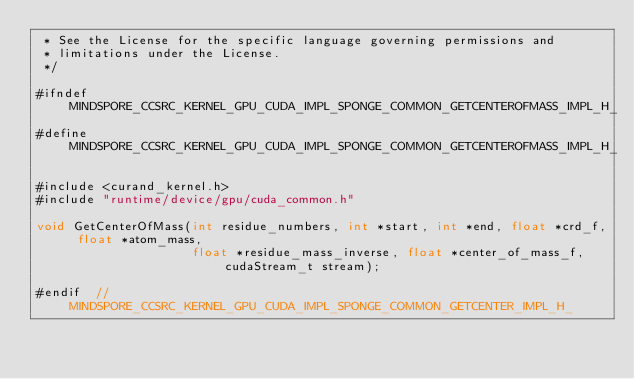<code> <loc_0><loc_0><loc_500><loc_500><_Cuda_> * See the License for the specific language governing permissions and
 * limitations under the License.
 */

#ifndef MINDSPORE_CCSRC_KERNEL_GPU_CUDA_IMPL_SPONGE_COMMON_GETCENTEROFMASS_IMPL_H_
#define MINDSPORE_CCSRC_KERNEL_GPU_CUDA_IMPL_SPONGE_COMMON_GETCENTEROFMASS_IMPL_H_

#include <curand_kernel.h>
#include "runtime/device/gpu/cuda_common.h"

void GetCenterOfMass(int residue_numbers, int *start, int *end, float *crd_f, float *atom_mass,
                     float *residue_mass_inverse, float *center_of_mass_f, cudaStream_t stream);

#endif  // MINDSPORE_CCSRC_KERNEL_GPU_CUDA_IMPL_SPONGE_COMMON_GETCENTER_IMPL_H_
</code> 